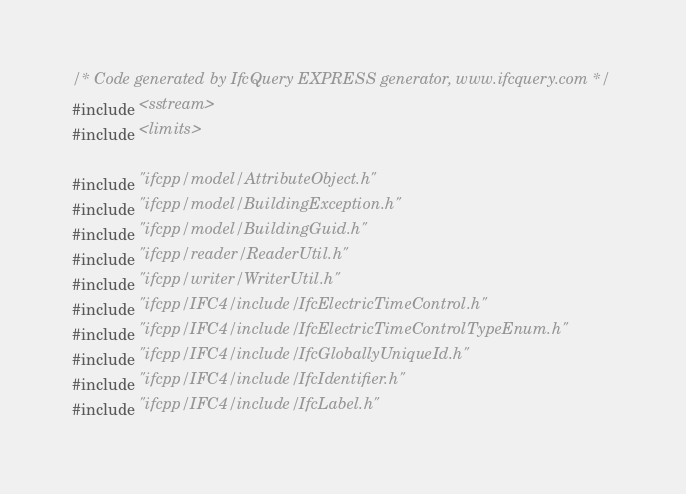<code> <loc_0><loc_0><loc_500><loc_500><_C++_>/* Code generated by IfcQuery EXPRESS generator, www.ifcquery.com */
#include <sstream>
#include <limits>

#include "ifcpp/model/AttributeObject.h"
#include "ifcpp/model/BuildingException.h"
#include "ifcpp/model/BuildingGuid.h"
#include "ifcpp/reader/ReaderUtil.h"
#include "ifcpp/writer/WriterUtil.h"
#include "ifcpp/IFC4/include/IfcElectricTimeControl.h"
#include "ifcpp/IFC4/include/IfcElectricTimeControlTypeEnum.h"
#include "ifcpp/IFC4/include/IfcGloballyUniqueId.h"
#include "ifcpp/IFC4/include/IfcIdentifier.h"
#include "ifcpp/IFC4/include/IfcLabel.h"</code> 